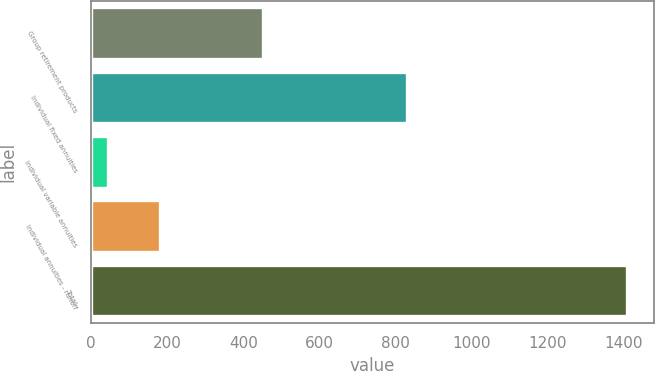Convert chart. <chart><loc_0><loc_0><loc_500><loc_500><bar_chart><fcel>Group retirement products<fcel>Individual fixed annuities<fcel>Individual variable annuities<fcel>Individual annuities - runoff<fcel>Total<nl><fcel>451<fcel>829<fcel>45<fcel>181.3<fcel>1408<nl></chart> 